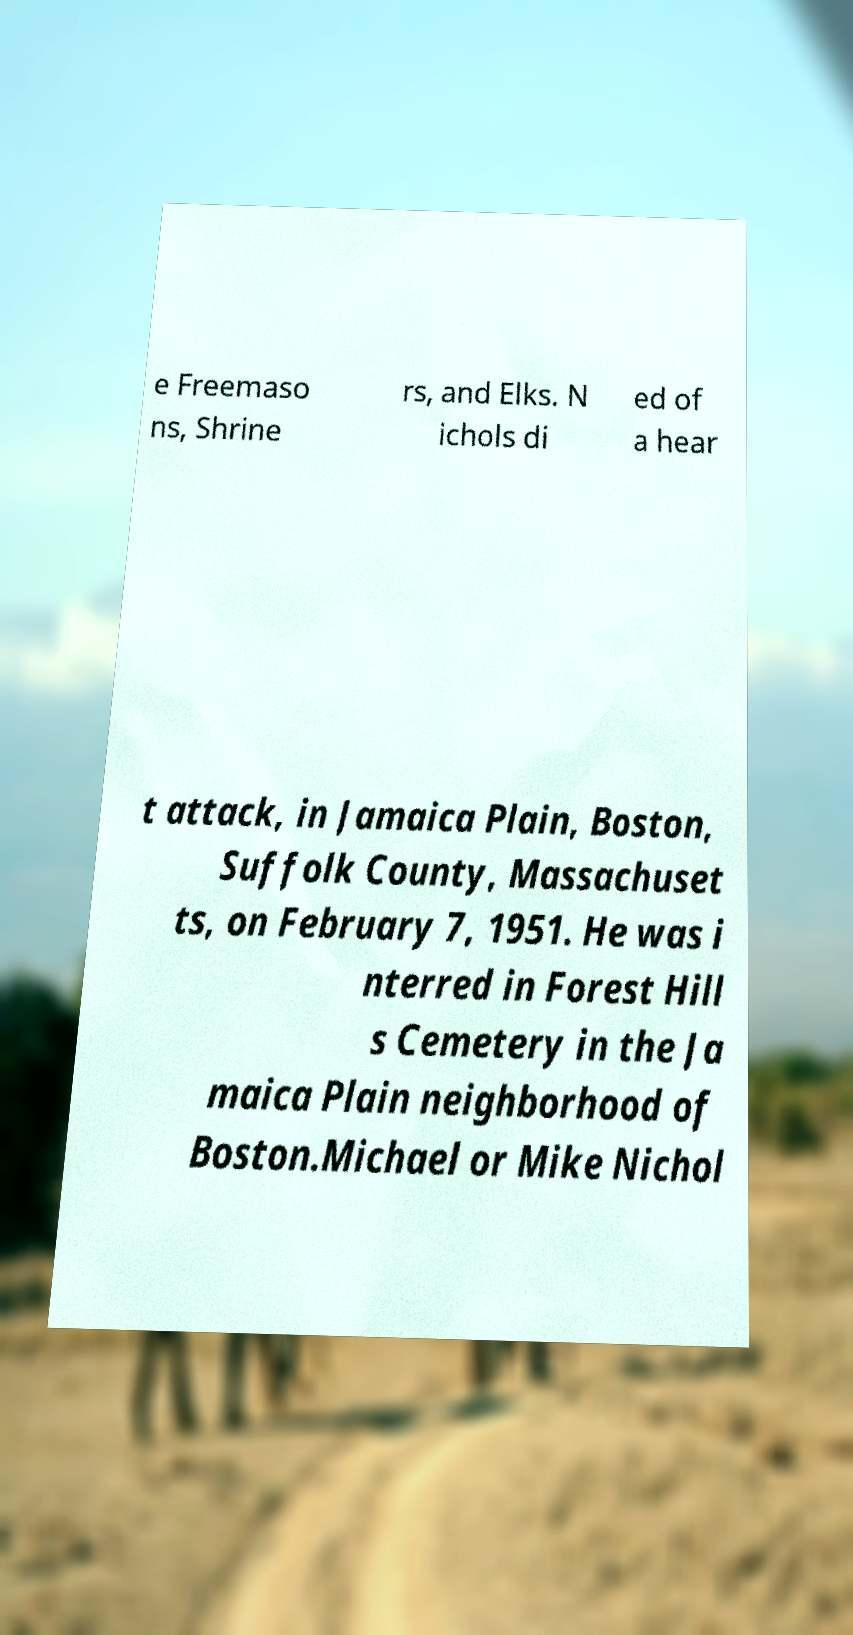There's text embedded in this image that I need extracted. Can you transcribe it verbatim? e Freemaso ns, Shrine rs, and Elks. N ichols di ed of a hear t attack, in Jamaica Plain, Boston, Suffolk County, Massachuset ts, on February 7, 1951. He was i nterred in Forest Hill s Cemetery in the Ja maica Plain neighborhood of Boston.Michael or Mike Nichol 